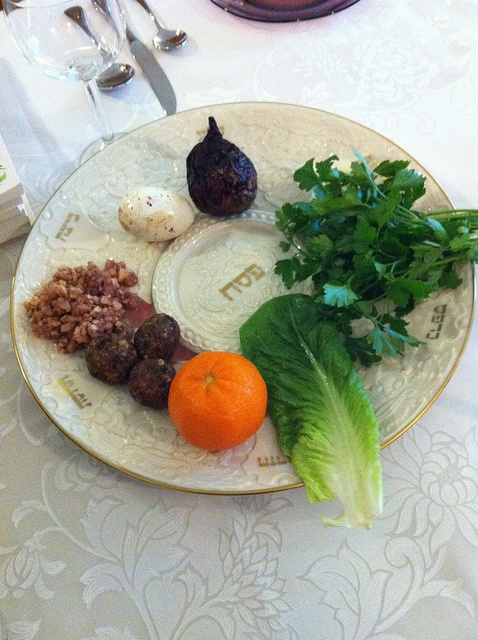Describe the objects in this image and their specific colors. I can see dining table in lightgray, darkgray, beige, black, and darkgreen tones, wine glass in maroon, lightgray, darkgray, and gray tones, orange in maroon, red, brown, and orange tones, knife in maroon, gray, and lightgray tones, and spoon in maroon, gray, darkgray, and lightgray tones in this image. 